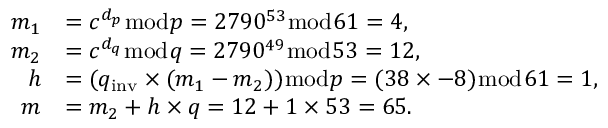Convert formula to latex. <formula><loc_0><loc_0><loc_500><loc_500>{ \begin{array} { r l } { m _ { 1 } } & { = c ^ { d _ { p } } { \bmod { p } } = 2 7 9 0 ^ { 5 3 } { \bmod { 6 } } 1 = 4 , } \\ { m _ { 2 } } & { = c ^ { d _ { q } } { \bmod { q } } = 2 7 9 0 ^ { 4 9 } { \bmod { 5 } } 3 = 1 2 , } \\ { h } & { = ( q _ { i n v } \times ( m _ { 1 } - m _ { 2 } ) ) { \bmod { p } } = ( 3 8 \times - 8 ) { \bmod { 6 } } 1 = 1 , } \\ { m } & { = m _ { 2 } + h \times q = 1 2 + 1 \times 5 3 = 6 5 . } \end{array} }</formula> 